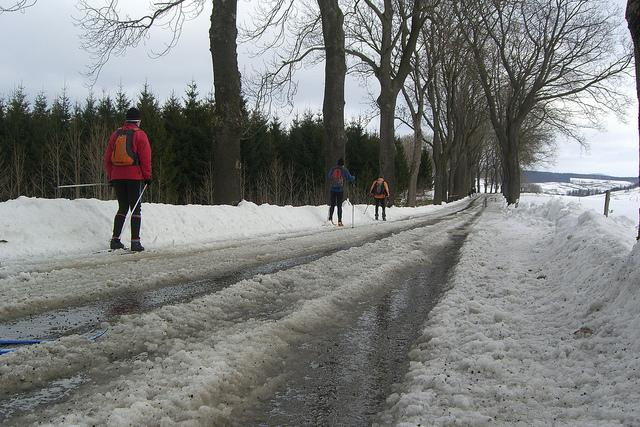What caused the deepest mushiest tracks here?

Choices:
A) trains
B) skiers
C) bears
D) automobiles automobiles 